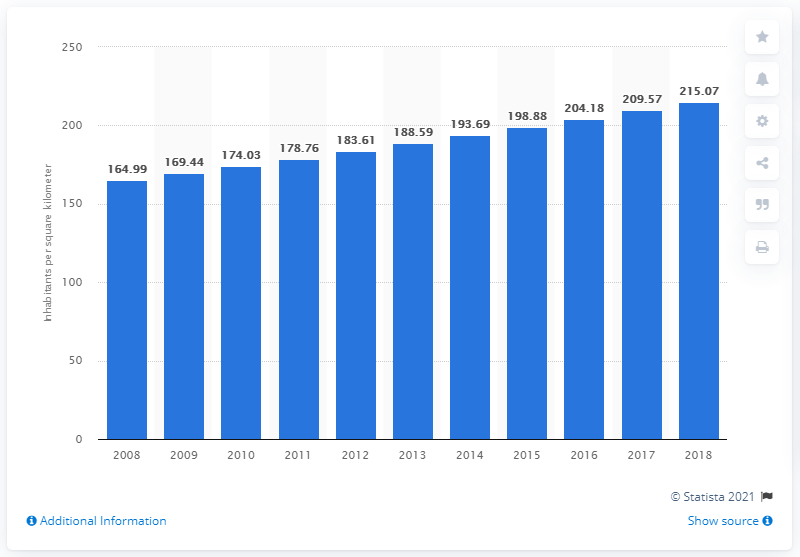Highlight a few significant elements in this photo. Nigeria's population density in 2018 was 215.07 people per square kilometer. 